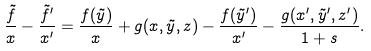Convert formula to latex. <formula><loc_0><loc_0><loc_500><loc_500>\frac { \tilde { f } } { x } - \frac { \tilde { f } ^ { \prime } } { x ^ { \prime } } = \frac { f ( \tilde { y } ) } { x } + g ( x , \tilde { y } , z ) - \frac { f ( \tilde { y } ^ { \prime } ) } { x ^ { \prime } } - \frac { g ( x ^ { \prime } , \tilde { y } ^ { \prime } , z ^ { \prime } ) } { 1 + s } .</formula> 